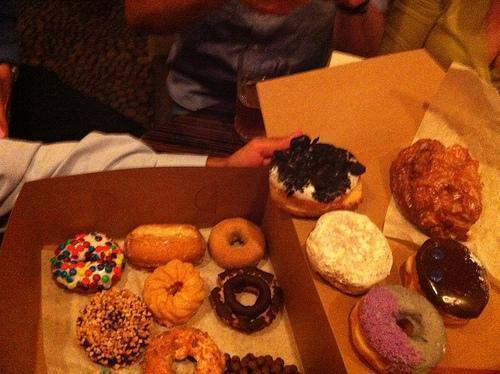How many donuts are shown?
Give a very brief answer. 13. How many donuts have chocolate frosting?
Give a very brief answer. 4. How many hands are holding the box?
Give a very brief answer. 1. How many boxes are there?
Give a very brief answer. 1. 